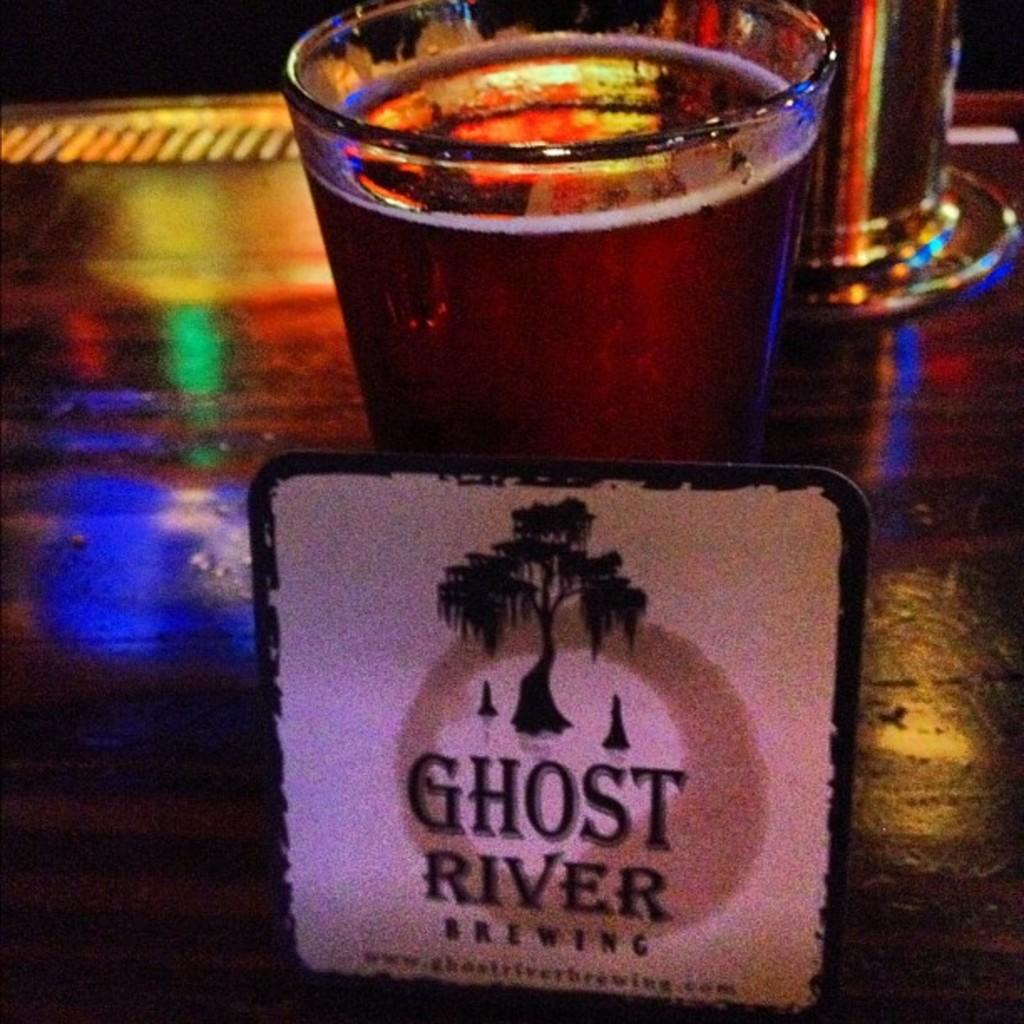<image>
Provide a brief description of the given image. A coaster of Ghost River Brewing with a sweeping tree on the coaster. 